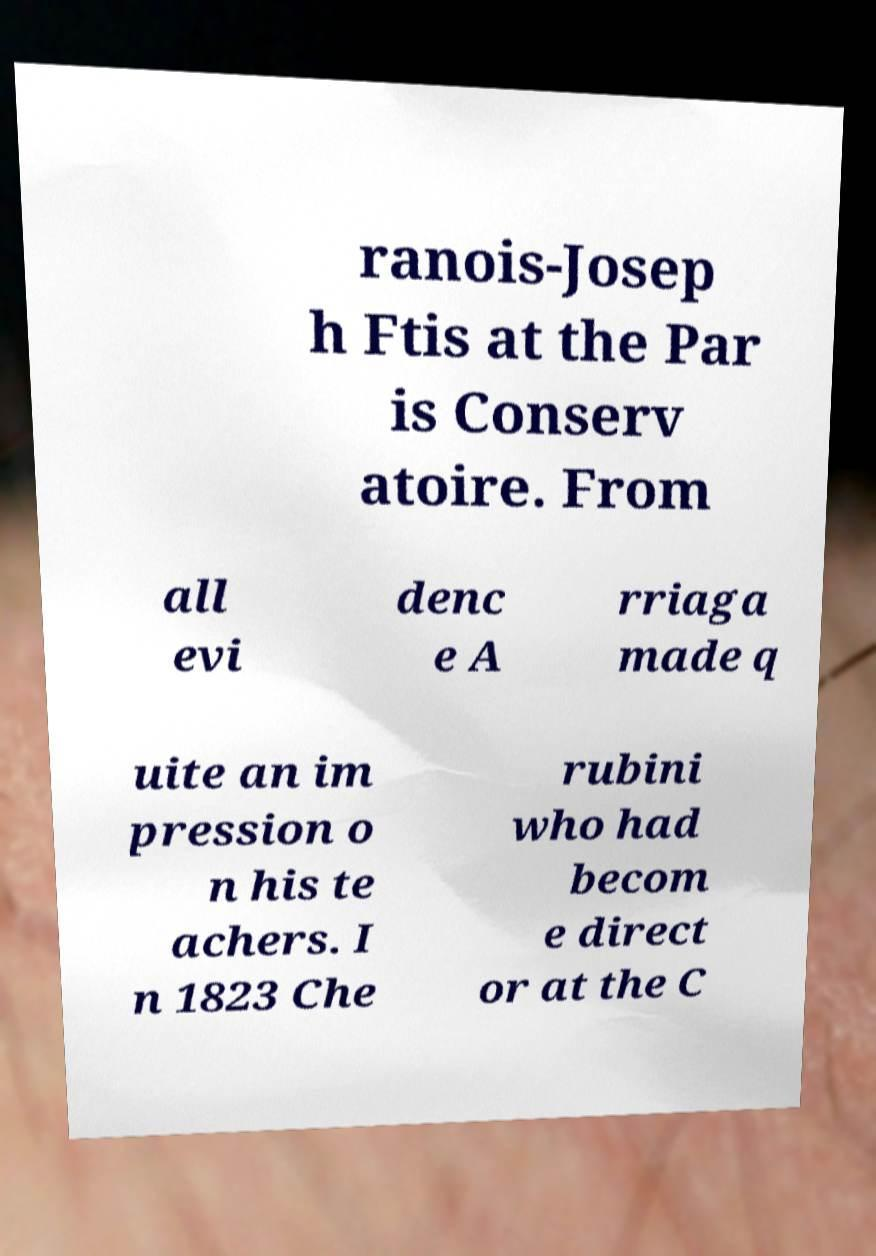Could you extract and type out the text from this image? ranois-Josep h Ftis at the Par is Conserv atoire. From all evi denc e A rriaga made q uite an im pression o n his te achers. I n 1823 Che rubini who had becom e direct or at the C 